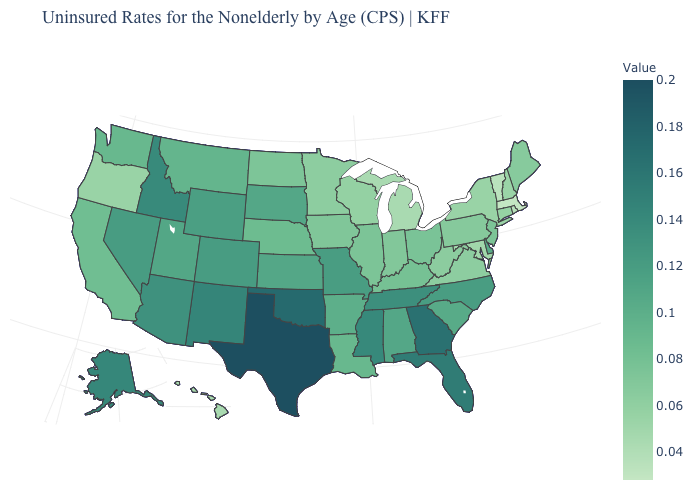Among the states that border Illinois , which have the highest value?
Keep it brief. Missouri. Does Delaware have a higher value than Oklahoma?
Concise answer only. No. Does the map have missing data?
Be succinct. No. Which states hav the highest value in the Northeast?
Write a very short answer. New Jersey. 